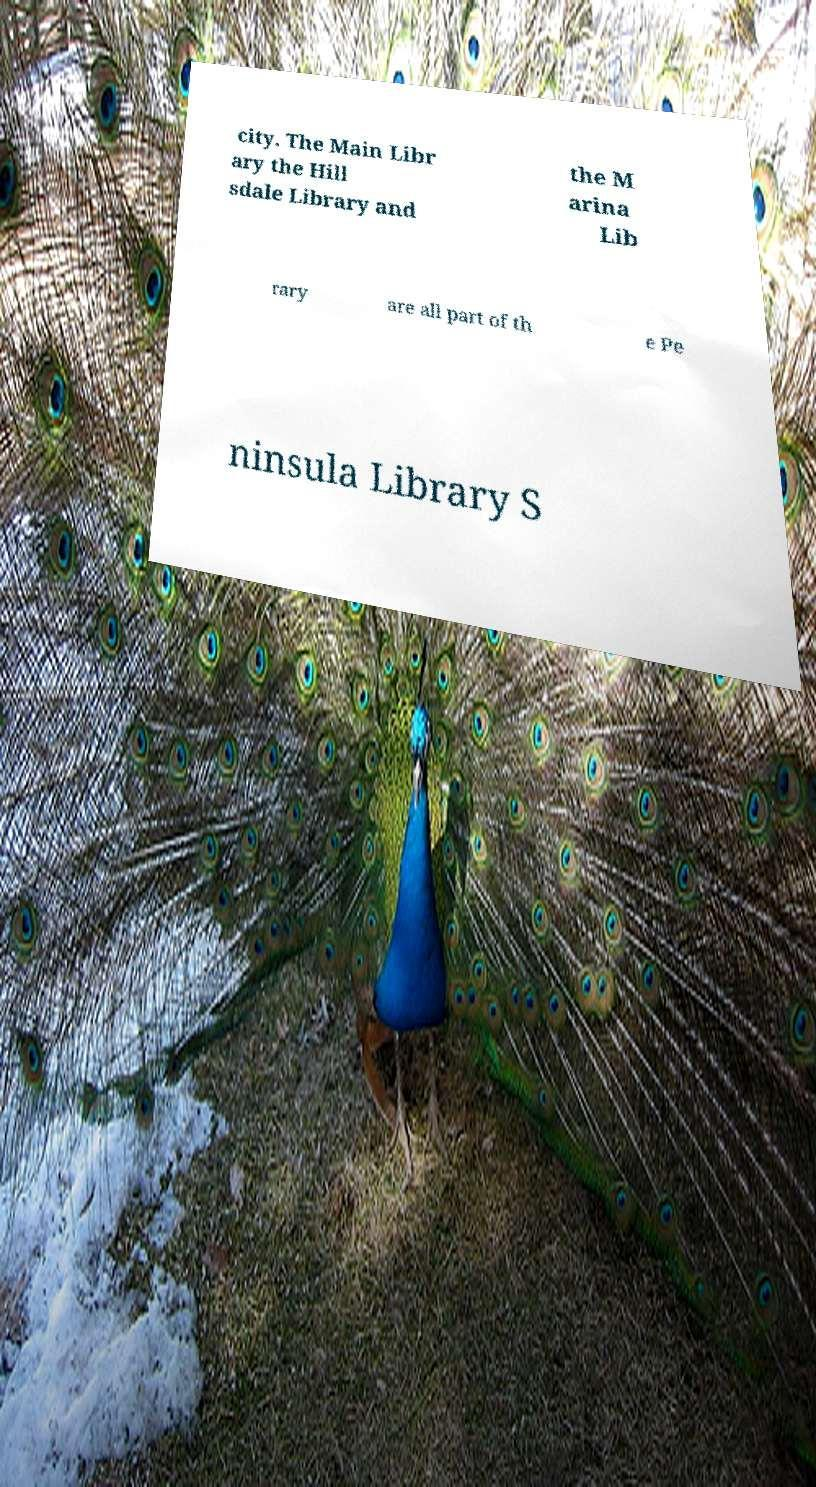For documentation purposes, I need the text within this image transcribed. Could you provide that? city. The Main Libr ary the Hill sdale Library and the M arina Lib rary are all part of th e Pe ninsula Library S 